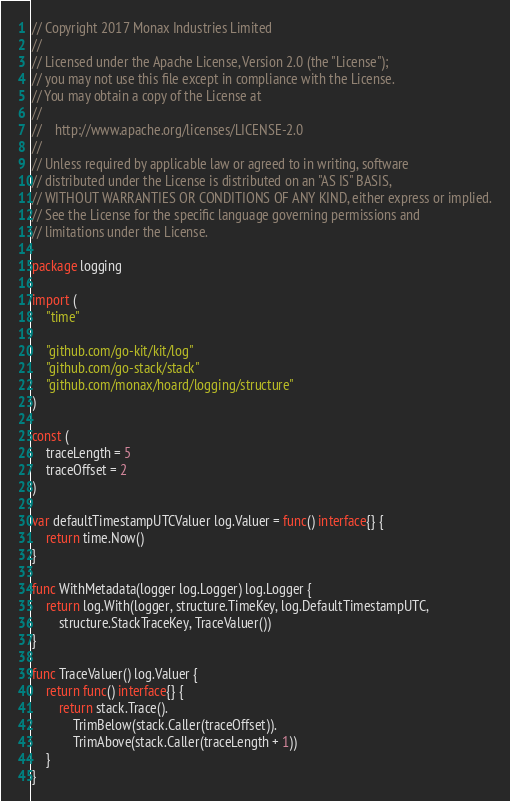Convert code to text. <code><loc_0><loc_0><loc_500><loc_500><_Go_>// Copyright 2017 Monax Industries Limited
//
// Licensed under the Apache License, Version 2.0 (the "License");
// you may not use this file except in compliance with the License.
// You may obtain a copy of the License at
//
//    http://www.apache.org/licenses/LICENSE-2.0
//
// Unless required by applicable law or agreed to in writing, software
// distributed under the License is distributed on an "AS IS" BASIS,
// WITHOUT WARRANTIES OR CONDITIONS OF ANY KIND, either express or implied.
// See the License for the specific language governing permissions and
// limitations under the License.

package logging

import (
	"time"

	"github.com/go-kit/kit/log"
	"github.com/go-stack/stack"
	"github.com/monax/hoard/logging/structure"
)

const (
	traceLength = 5
	traceOffset = 2
)

var defaultTimestampUTCValuer log.Valuer = func() interface{} {
	return time.Now()
}

func WithMetadata(logger log.Logger) log.Logger {
	return log.With(logger, structure.TimeKey, log.DefaultTimestampUTC,
		structure.StackTraceKey, TraceValuer())
}

func TraceValuer() log.Valuer {
	return func() interface{} {
		return stack.Trace().
			TrimBelow(stack.Caller(traceOffset)).
			TrimAbove(stack.Caller(traceLength + 1))
	}
}
</code> 